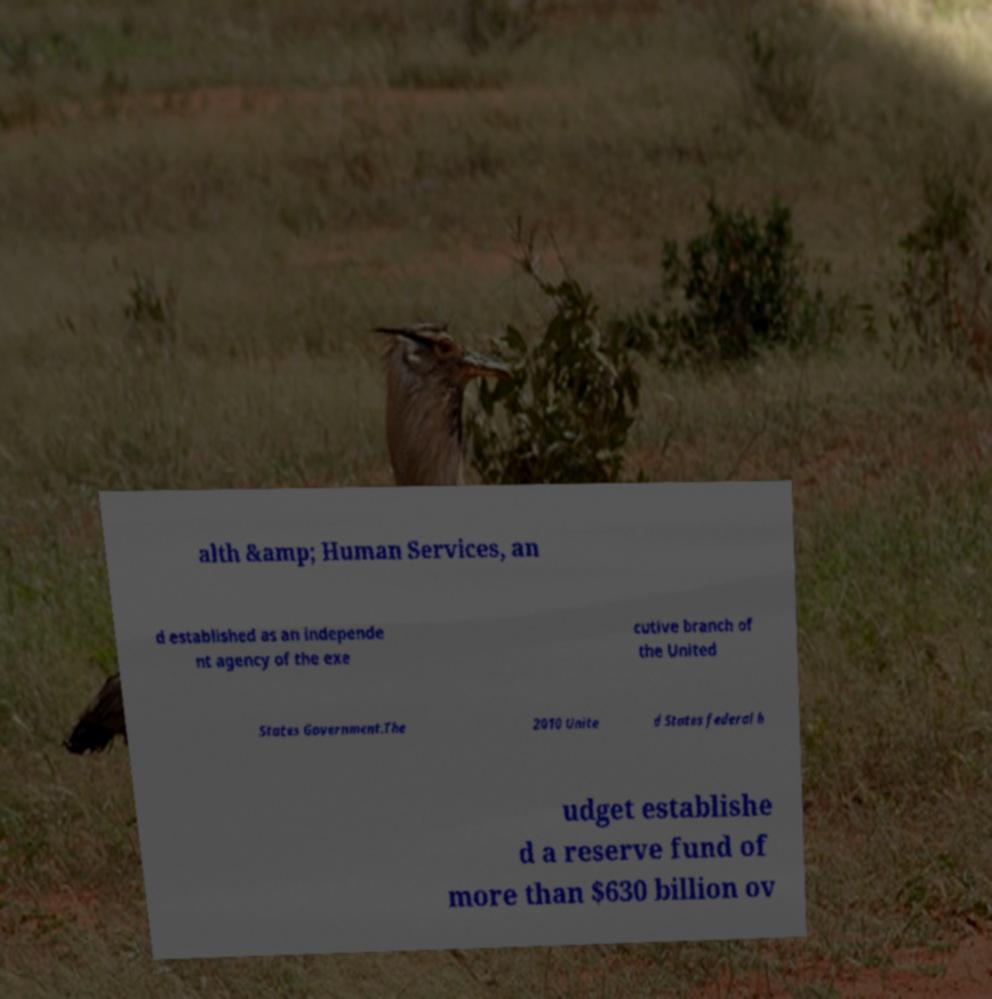Could you extract and type out the text from this image? alth &amp; Human Services, an d established as an independe nt agency of the exe cutive branch of the United States Government.The 2010 Unite d States federal b udget establishe d a reserve fund of more than $630 billion ov 